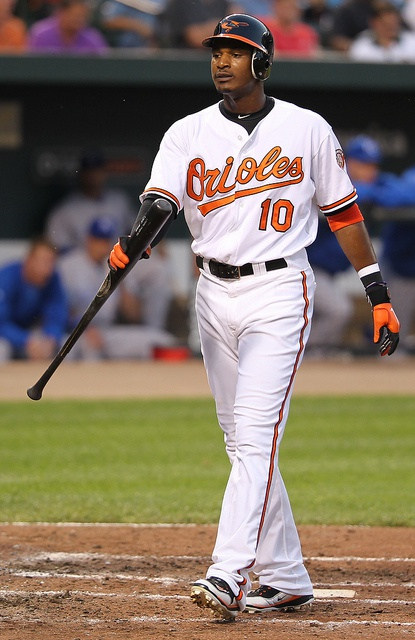Describe the objects in this image and their specific colors. I can see people in brown, lavender, black, darkgray, and gray tones, people in brown and gray tones, people in brown, navy, black, and gray tones, baseball bat in brown, black, and gray tones, and people in brown, purple, and maroon tones in this image. 